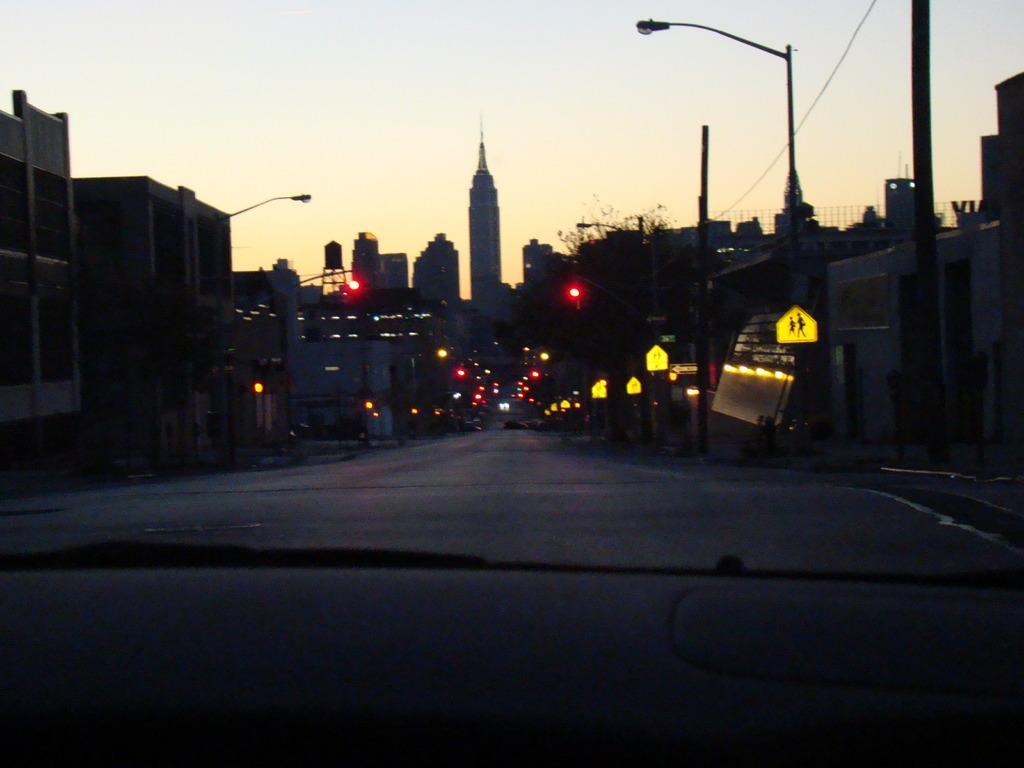What is the main feature of the image? There is a road in the image. What else can be seen along the road? There are lights and buildings visible in the image. What is visible at the top of the image? The sky is visible at the top of the image. What type of authority is present in the image? There is no specific authority figure present in the image; it primarily features a road, lights, buildings, and the sky. 